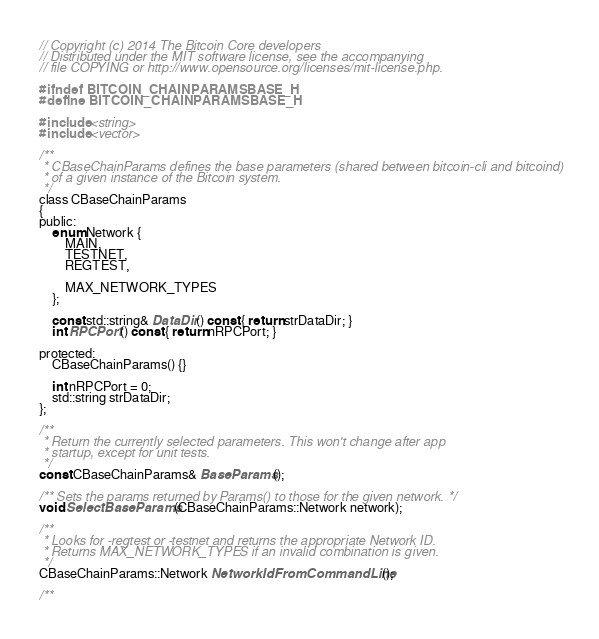Convert code to text. <code><loc_0><loc_0><loc_500><loc_500><_C_>// Copyright (c) 2014 The Bitcoin Core developers
// Distributed under the MIT software license, see the accompanying
// file COPYING or http://www.opensource.org/licenses/mit-license.php.

#ifndef BITCOIN_CHAINPARAMSBASE_H
#define BITCOIN_CHAINPARAMSBASE_H

#include <string>
#include <vector>

/**
 * CBaseChainParams defines the base parameters (shared between bitcoin-cli and bitcoind)
 * of a given instance of the Bitcoin system.
 */
class CBaseChainParams
{
public:
    enum Network {
        MAIN,
        TESTNET,
        REGTEST,

        MAX_NETWORK_TYPES
    };

    const std::string& DataDir() const { return strDataDir; }
    int RPCPort() const { return nRPCPort; }

protected:
    CBaseChainParams() {}

    int nRPCPort = 0;
    std::string strDataDir;
};

/**
 * Return the currently selected parameters. This won't change after app
 * startup, except for unit tests.
 */
const CBaseChainParams& BaseParams();

/** Sets the params returned by Params() to those for the given network. */
void SelectBaseParams(CBaseChainParams::Network network);

/**
 * Looks for -regtest or -testnet and returns the appropriate Network ID.
 * Returns MAX_NETWORK_TYPES if an invalid combination is given.
 */
CBaseChainParams::Network NetworkIdFromCommandLine();

/**</code> 